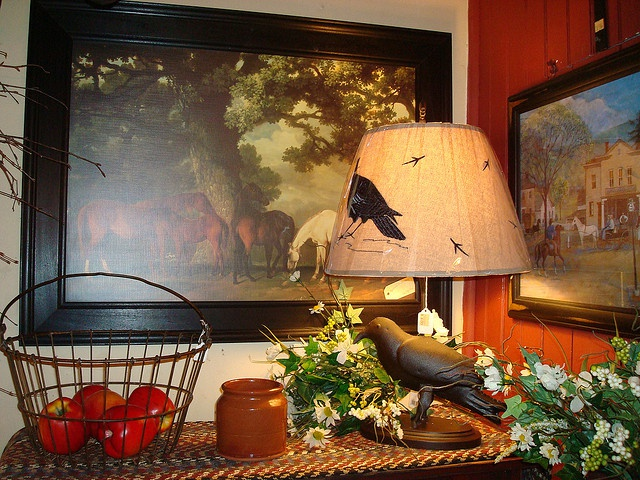Describe the objects in this image and their specific colors. I can see apple in black, maroon, and brown tones, bird in black, gray, maroon, and olive tones, cup in black, maroon, and brown tones, and bird in black, maroon, and gray tones in this image. 